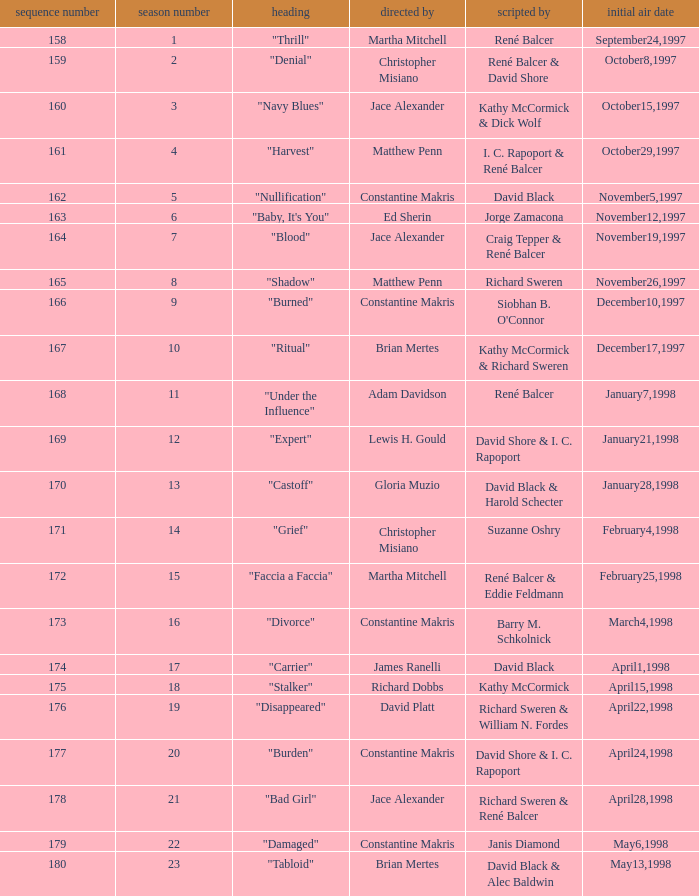The first episode in this season had what number in the series?  158.0. 